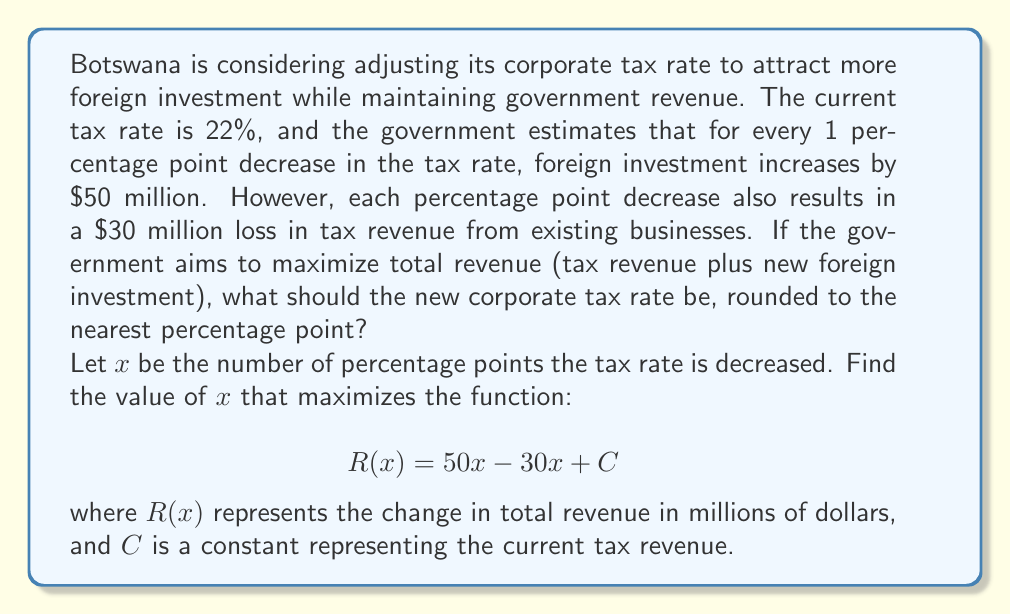Solve this math problem. Let's solve this step-by-step:

1) The function $R(x) = 50x - 30x + C$ can be simplified to:
   $$R(x) = 20x + C$$

2) To find the maximum value of this linear function, we need to consider the constraints:
   - The tax rate can't be negative, so $x \leq 22$ (since the current rate is 22%)
   - $x$ must be non-negative (we can't increase the tax rate)

3) Since $R(x)$ is a linear function with a positive slope (20), it will reach its maximum value at the highest possible value of $x$ within our constraints.

4) Therefore, the maximum occurs at $x = 22$, which corresponds to reducing the tax rate to 0%.

5) However, a 0% tax rate is not practical. We need to find a balance that significantly increases revenue while maintaining a reasonable tax rate.

6) Let's calculate the revenue change for a few values:
   - At $x = 5$: $R(5) = 20(5) = 100$ million
   - At $x = 10$: $R(10) = 20(10) = 200$ million
   - At $x = 15$: $R(15) = 20(15) = 300$ million

7) A decrease of 15 percentage points seems to offer a substantial revenue increase while still maintaining a 7% tax rate.

8) Rounding to the nearest percentage point, we should decrease the tax rate by 15 percentage points.
Answer: 7% 